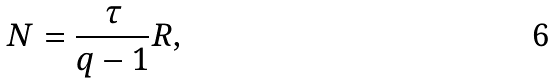Convert formula to latex. <formula><loc_0><loc_0><loc_500><loc_500>N = \frac { \tau } { q - 1 } R ,</formula> 